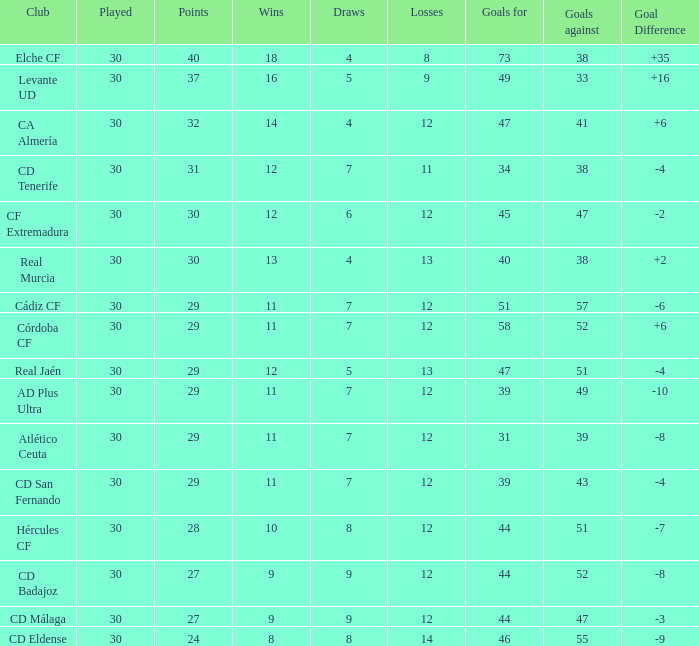What is the highest amount of goals with more than 51 goals against and less than 30 played? None. 